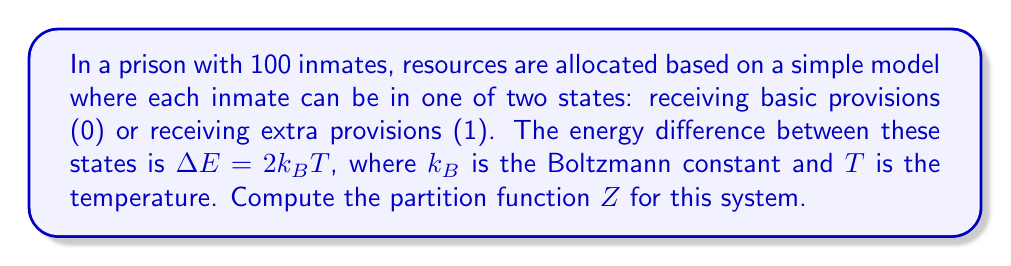Show me your answer to this math problem. Let's approach this step-by-step:

1) The partition function $Z$ for a system with discrete energy levels is given by:

   $$Z = \sum_i g_i e^{-E_i/k_BT}$$

   where $g_i$ is the degeneracy of state $i$ and $E_i$ is the energy of state $i$.

2) In our case, we have two states: 
   - State 0: Basic provisions, $E_0 = 0$
   - State 1: Extra provisions, $E_1 = \Delta E = 2k_BT$

3) Each inmate can be in either state, so for a single inmate:

   $$Z_1 = e^{-E_0/k_BT} + e^{-E_1/k_BT} = 1 + e^{-2}$$

4) Since there are 100 inmates and they are independent, the total partition function is the product of the individual partition functions:

   $$Z = (Z_1)^{100} = (1 + e^{-2})^{100}$$

5) We can simplify this:

   $$Z = (1 + e^{-2})^{100} \approx (1.135)^{100} \approx 1.37 \times 10^6$$
Answer: $Z \approx 1.37 \times 10^6$ 